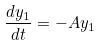<formula> <loc_0><loc_0><loc_500><loc_500>\frac { d y _ { 1 } } { d t } = - A y _ { 1 }</formula> 